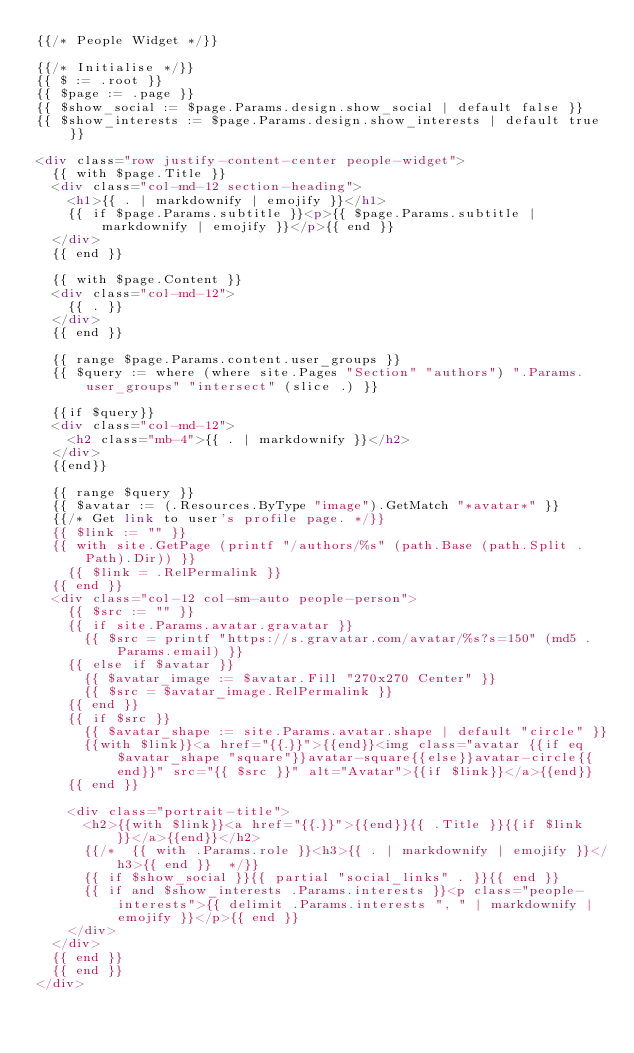Convert code to text. <code><loc_0><loc_0><loc_500><loc_500><_HTML_>{{/* People Widget */}}

{{/* Initialise */}}
{{ $ := .root }}
{{ $page := .page }}
{{ $show_social := $page.Params.design.show_social | default false }}
{{ $show_interests := $page.Params.design.show_interests | default true }}

<div class="row justify-content-center people-widget">
  {{ with $page.Title }}
  <div class="col-md-12 section-heading">
    <h1>{{ . | markdownify | emojify }}</h1>
    {{ if $page.Params.subtitle }}<p>{{ $page.Params.subtitle | markdownify | emojify }}</p>{{ end }}
  </div>
  {{ end }}

  {{ with $page.Content }}
  <div class="col-md-12">
    {{ . }}
  </div>
  {{ end }}

  {{ range $page.Params.content.user_groups }}
  {{ $query := where (where site.Pages "Section" "authors") ".Params.user_groups" "intersect" (slice .) }}

  {{if $query}}
  <div class="col-md-12">
    <h2 class="mb-4">{{ . | markdownify }}</h2>
  </div>
  {{end}}

  {{ range $query }}
  {{ $avatar := (.Resources.ByType "image").GetMatch "*avatar*" }}
  {{/* Get link to user's profile page. */}}
  {{ $link := "" }}
  {{ with site.GetPage (printf "/authors/%s" (path.Base (path.Split .Path).Dir)) }}
    {{ $link = .RelPermalink }}
  {{ end }}
  <div class="col-12 col-sm-auto people-person">
    {{ $src := "" }}
    {{ if site.Params.avatar.gravatar }}
      {{ $src = printf "https://s.gravatar.com/avatar/%s?s=150" (md5 .Params.email) }}
    {{ else if $avatar }}
      {{ $avatar_image := $avatar.Fill "270x270 Center" }}
      {{ $src = $avatar_image.RelPermalink }}
    {{ end }}
    {{ if $src }}
      {{ $avatar_shape := site.Params.avatar.shape | default "circle" }}
      {{with $link}}<a href="{{.}}">{{end}}<img class="avatar {{if eq $avatar_shape "square"}}avatar-square{{else}}avatar-circle{{end}}" src="{{ $src }}" alt="Avatar">{{if $link}}</a>{{end}}
    {{ end }}

    <div class="portrait-title">
      <h2>{{with $link}}<a href="{{.}}">{{end}}{{ .Title }}{{if $link}}</a>{{end}}</h2>
      {{/*  {{ with .Params.role }}<h3>{{ . | markdownify | emojify }}</h3>{{ end }}  */}}
      {{ if $show_social }}{{ partial "social_links" . }}{{ end }}
      {{ if and $show_interests .Params.interests }}<p class="people-interests">{{ delimit .Params.interests ", " | markdownify | emojify }}</p>{{ end }}
    </div>
  </div>
  {{ end }}
  {{ end }}
</div>
</code> 